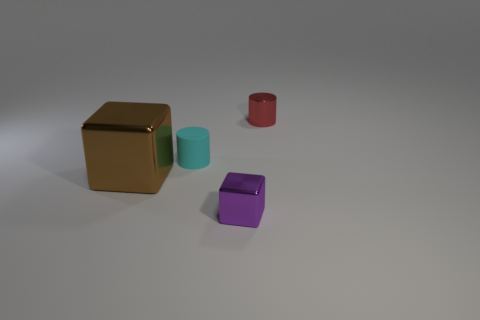Is there any other thing that has the same material as the small cyan thing?
Offer a terse response. No. There is another metallic thing that is the same shape as the small cyan thing; what is its size?
Give a very brief answer. Small. How many other things are made of the same material as the small red object?
Your response must be concise. 2. What is the material of the large brown block?
Offer a very short reply. Metal. Do the cube to the right of the tiny rubber object and the shiny object that is behind the large brown thing have the same color?
Your response must be concise. No. Are there more small cyan rubber objects that are in front of the brown cube than tiny metal things?
Offer a very short reply. No. What number of other objects are there of the same color as the small cube?
Your answer should be very brief. 0. There is a object that is to the left of the rubber thing; is its size the same as the cyan rubber cylinder?
Your response must be concise. No. Is there a yellow ball of the same size as the red cylinder?
Give a very brief answer. No. What color is the shiny cube that is to the left of the cyan matte object?
Make the answer very short. Brown. 